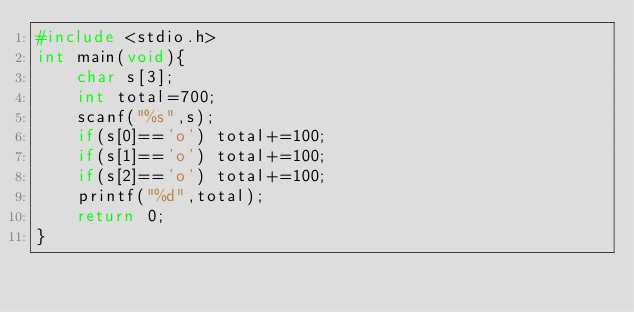Convert code to text. <code><loc_0><loc_0><loc_500><loc_500><_C_>#include <stdio.h>
int main(void){
    char s[3];
    int total=700;
    scanf("%s",s);
    if(s[0]=='o') total+=100;
    if(s[1]=='o') total+=100;
    if(s[2]=='o') total+=100;
    printf("%d",total);
    return 0;
}</code> 